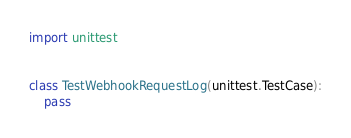Convert code to text. <code><loc_0><loc_0><loc_500><loc_500><_Python_>import unittest


class TestWebhookRequestLog(unittest.TestCase):
	pass
</code> 